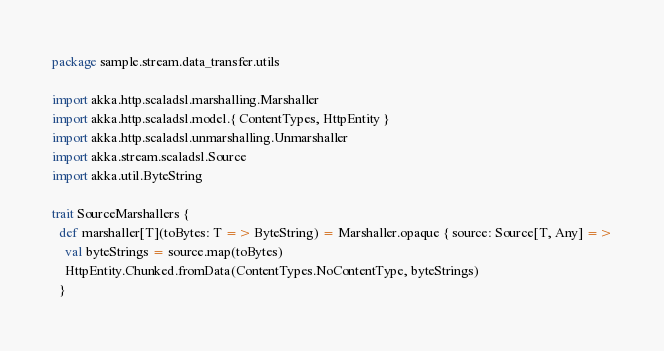<code> <loc_0><loc_0><loc_500><loc_500><_Scala_>package sample.stream.data_transfer.utils

import akka.http.scaladsl.marshalling.Marshaller
import akka.http.scaladsl.model.{ ContentTypes, HttpEntity }
import akka.http.scaladsl.unmarshalling.Unmarshaller
import akka.stream.scaladsl.Source
import akka.util.ByteString

trait SourceMarshallers {
  def marshaller[T](toBytes: T => ByteString) = Marshaller.opaque { source: Source[T, Any] =>
    val byteStrings = source.map(toBytes)
    HttpEntity.Chunked.fromData(ContentTypes.NoContentType, byteStrings)
  }
</code> 